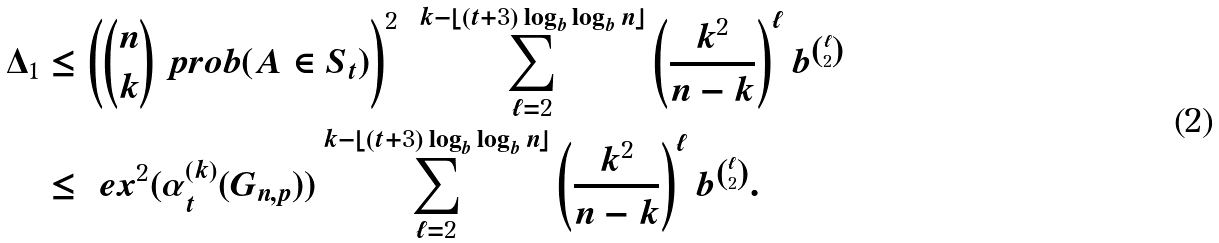<formula> <loc_0><loc_0><loc_500><loc_500>\Delta _ { 1 } & \leq \left ( \binom { n } { k } \ p r o b ( A \in S _ { t } ) \right ) ^ { 2 } \ \sum _ { \ell = 2 } ^ { k - \lfloor ( t + 3 ) \log _ { b } \log _ { b } n \rfloor } \left ( \frac { k ^ { 2 } } { n - k } \right ) ^ { \ell } b ^ { \binom { \ell } { 2 } } \\ & \leq \ e x ^ { 2 } ( \alpha _ { t } ^ { ( k ) } ( G _ { n , p } ) ) \sum _ { \ell = 2 } ^ { k - \lfloor ( t + 3 ) \log _ { b } \log _ { b } n \rfloor } \left ( \frac { k ^ { 2 } } { n - k } \right ) ^ { \ell } b ^ { \binom { \ell } { 2 } } .</formula> 